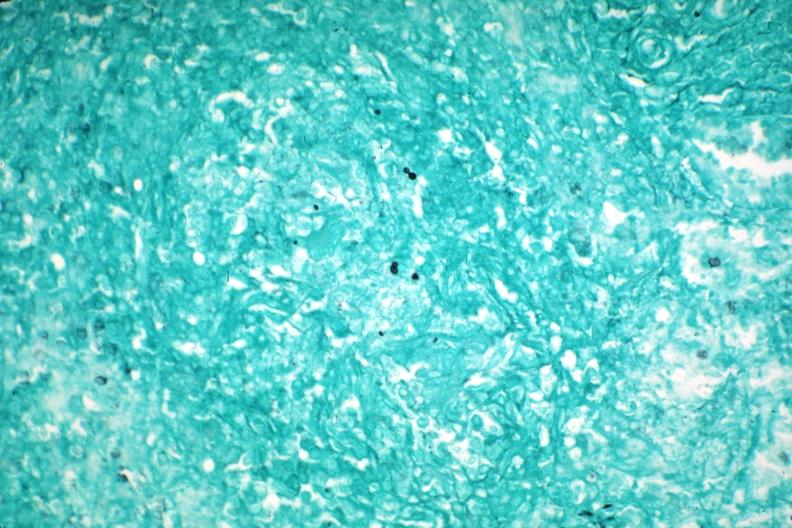what is present?
Answer the question using a single word or phrase. Hematologic 